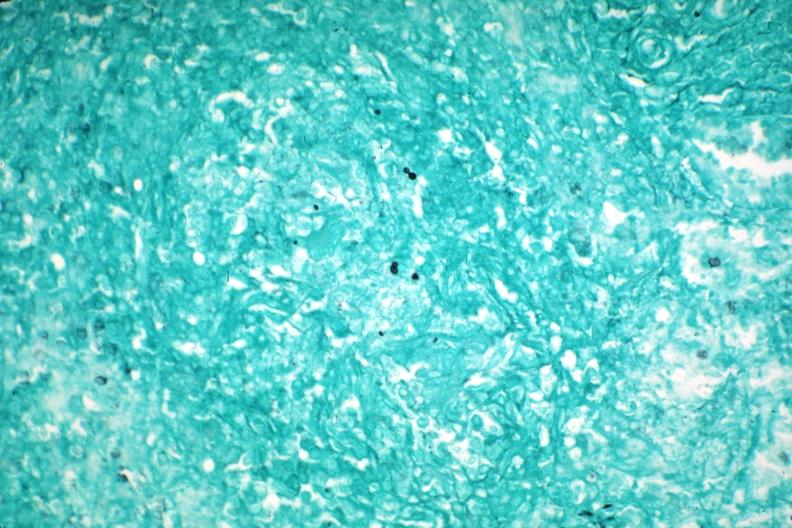what is present?
Answer the question using a single word or phrase. Hematologic 